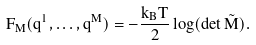Convert formula to latex. <formula><loc_0><loc_0><loc_500><loc_500>F _ { M } ( q ^ { 1 } , \dots , q ^ { M } ) = - \frac { k _ { B } T } { 2 } \log ( \det \tilde { M } ) .</formula> 